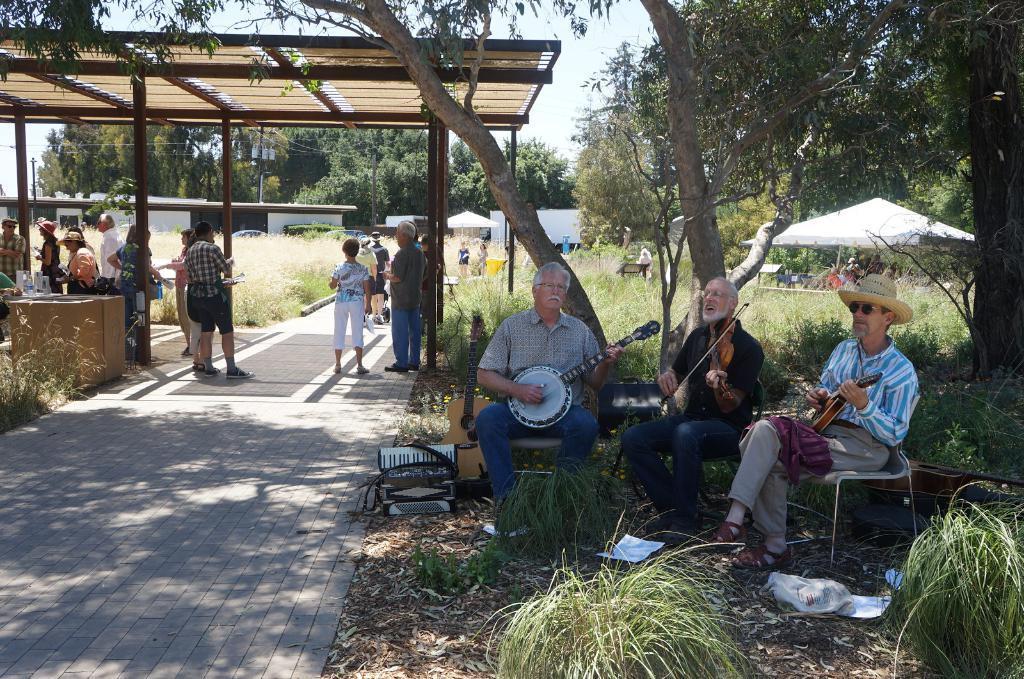In one or two sentences, can you explain what this image depicts? In this image there are people standing and some of them are sitting and playing musical instruments. At the bottom there is grass. In the background there are trees, sheds and sky. 